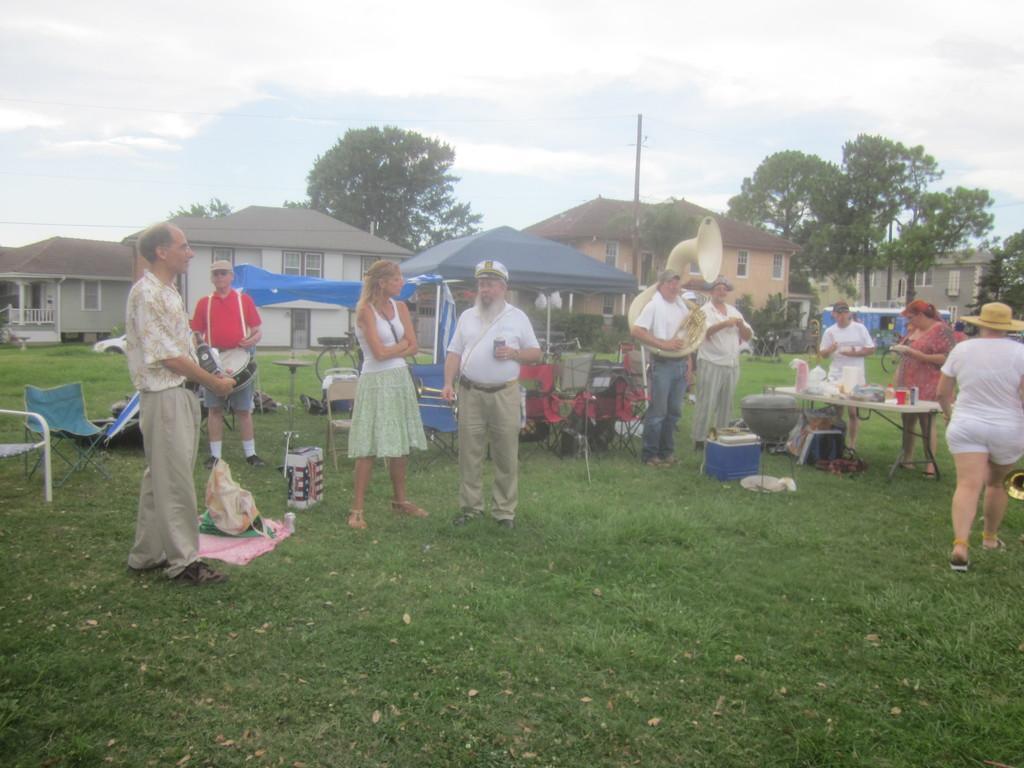In one or two sentences, can you explain what this image depicts? In this image there are some persons standing and some of them are playing some musical instruments, and also there are some tables and chairs. On the tables there are some objects and at the bottom there is grass, on the grass there are some boxes, baskets, clothes and some other objects. In the center there is a tent and some poles and chairs, and in the background there are some houses, trees, pole and at the top of the image there is sky. 